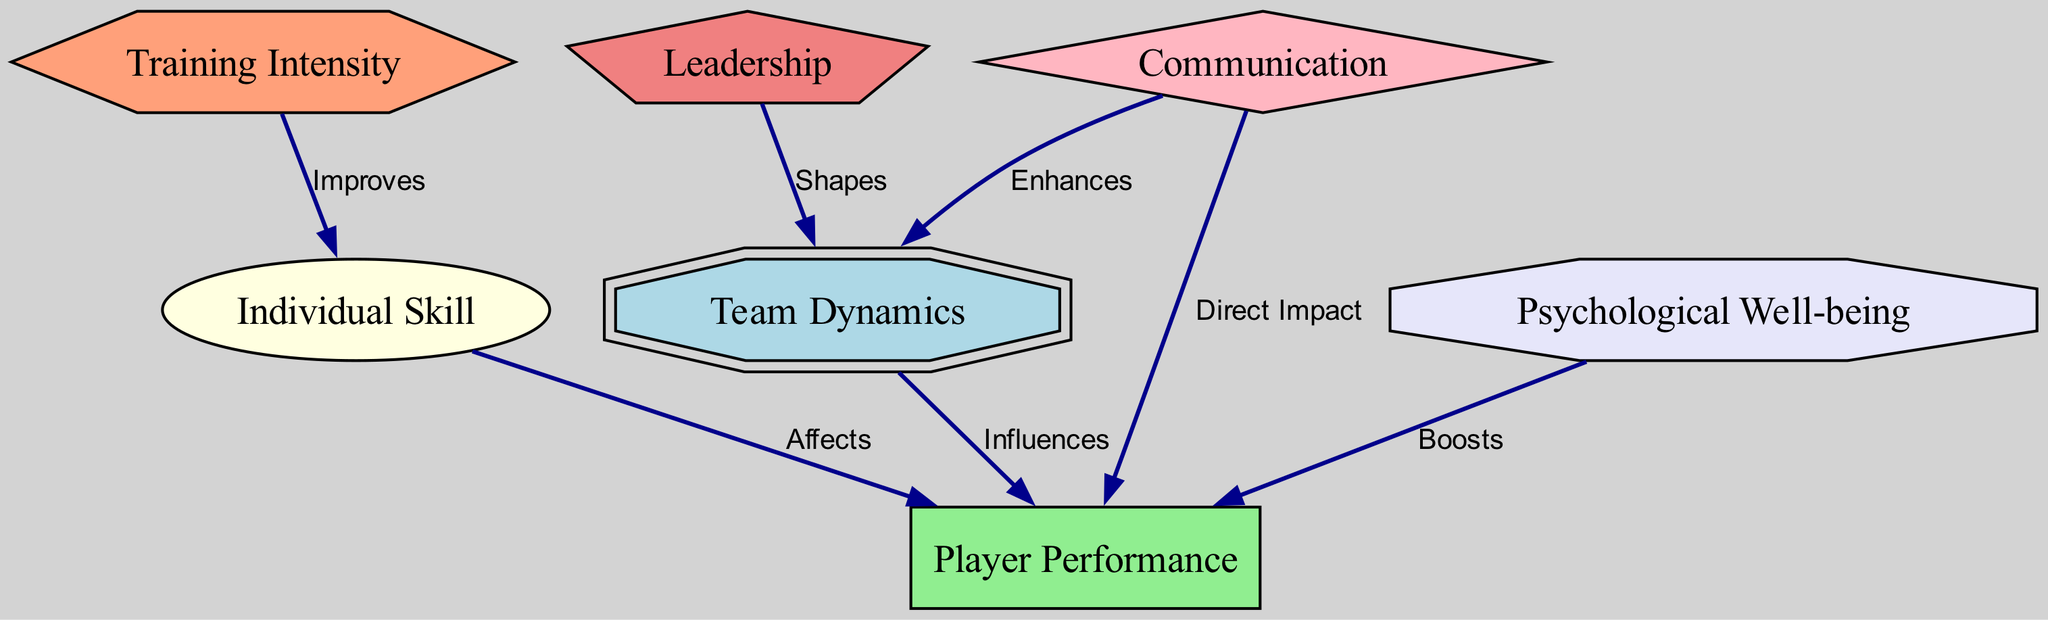What is the total number of nodes in the diagram? The diagram lists seven distinct nodes, including "Team Dynamics," "Player Performance," "Individual Skill," "Communication," "Leadership," "Training Intensity," and "Psychological Well-being." Counting these gives a total of seven nodes.
Answer: 7 What relationship exists between "Communication" and "Team Dynamics"? The diagram indicates that "Communication" enhances "Team Dynamics," showing a positive influence from communication on the effectiveness of team dynamics.
Answer: Enhances Which node directly impacts "Player Performance"? The diagram shows that "Communication" has a direct impact on "Player Performance," meaning that effective communication directly affects how players perform.
Answer: Direct Impact How does "Training Intensity" relate to "Individual Skill"? According to the diagram, "Training Intensity" improves "Individual Skill," meaning that the rigor of training can enhance a player's skills individually.
Answer: Improves What influences "Player Performance" in a direct manner? The diagram highlights that both "Individual Skill" and "Communication" have a direct influence on "Player Performance," indicating that both personal skills and team communication can affect performance.
Answer: Individual Skill, Communication What is the role of "Leadership" in relation to "Team Dynamics"? The diagram illustrates that "Leadership" shapes "Team Dynamics," which implies that the style and effectiveness of leadership directly influence how the team operates and interacts.
Answer: Shapes What is the total number of edges in the diagram? The diagram displays six edges connecting the nodes, representing the various relationships among them. Counting these shows there are six edges in total.
Answer: 6 Which node boosts "Player Performance"? The diagram specifies that "Psychological Well-being" boosts "Player Performance," indicating that mental health and well-being play a crucial role in how players perform.
Answer: Boosts How does "Communication" affect both "Team Dynamics" and "Player Performance"? In the diagram, "Communication" enhances "Team Dynamics" and also has a direct impact on "Player Performance," meaning effective communication improves both team interaction and individual performance levels.
Answer: Enhances, Direct Impact 